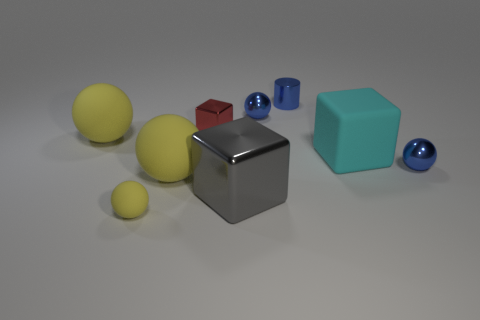Does the big rubber object behind the big cyan rubber thing have the same color as the large metal cube?
Your response must be concise. No. What shape is the red thing that is the same size as the metallic cylinder?
Make the answer very short. Cube. How many other objects are there of the same color as the big shiny object?
Ensure brevity in your answer.  0. How many other objects are there of the same material as the cyan block?
Your answer should be very brief. 3. Does the gray block have the same size as the blue metal ball behind the small metallic block?
Your response must be concise. No. What is the color of the big metal object?
Make the answer very short. Gray. There is a rubber thing in front of the big yellow object in front of the small metallic ball in front of the cyan matte block; what shape is it?
Your answer should be very brief. Sphere. There is a red cube in front of the small blue metallic ball behind the small red metallic block; what is it made of?
Keep it short and to the point. Metal. There is a small yellow thing that is made of the same material as the big cyan object; what shape is it?
Your answer should be compact. Sphere. Are there any other things that are the same shape as the gray object?
Keep it short and to the point. Yes. 